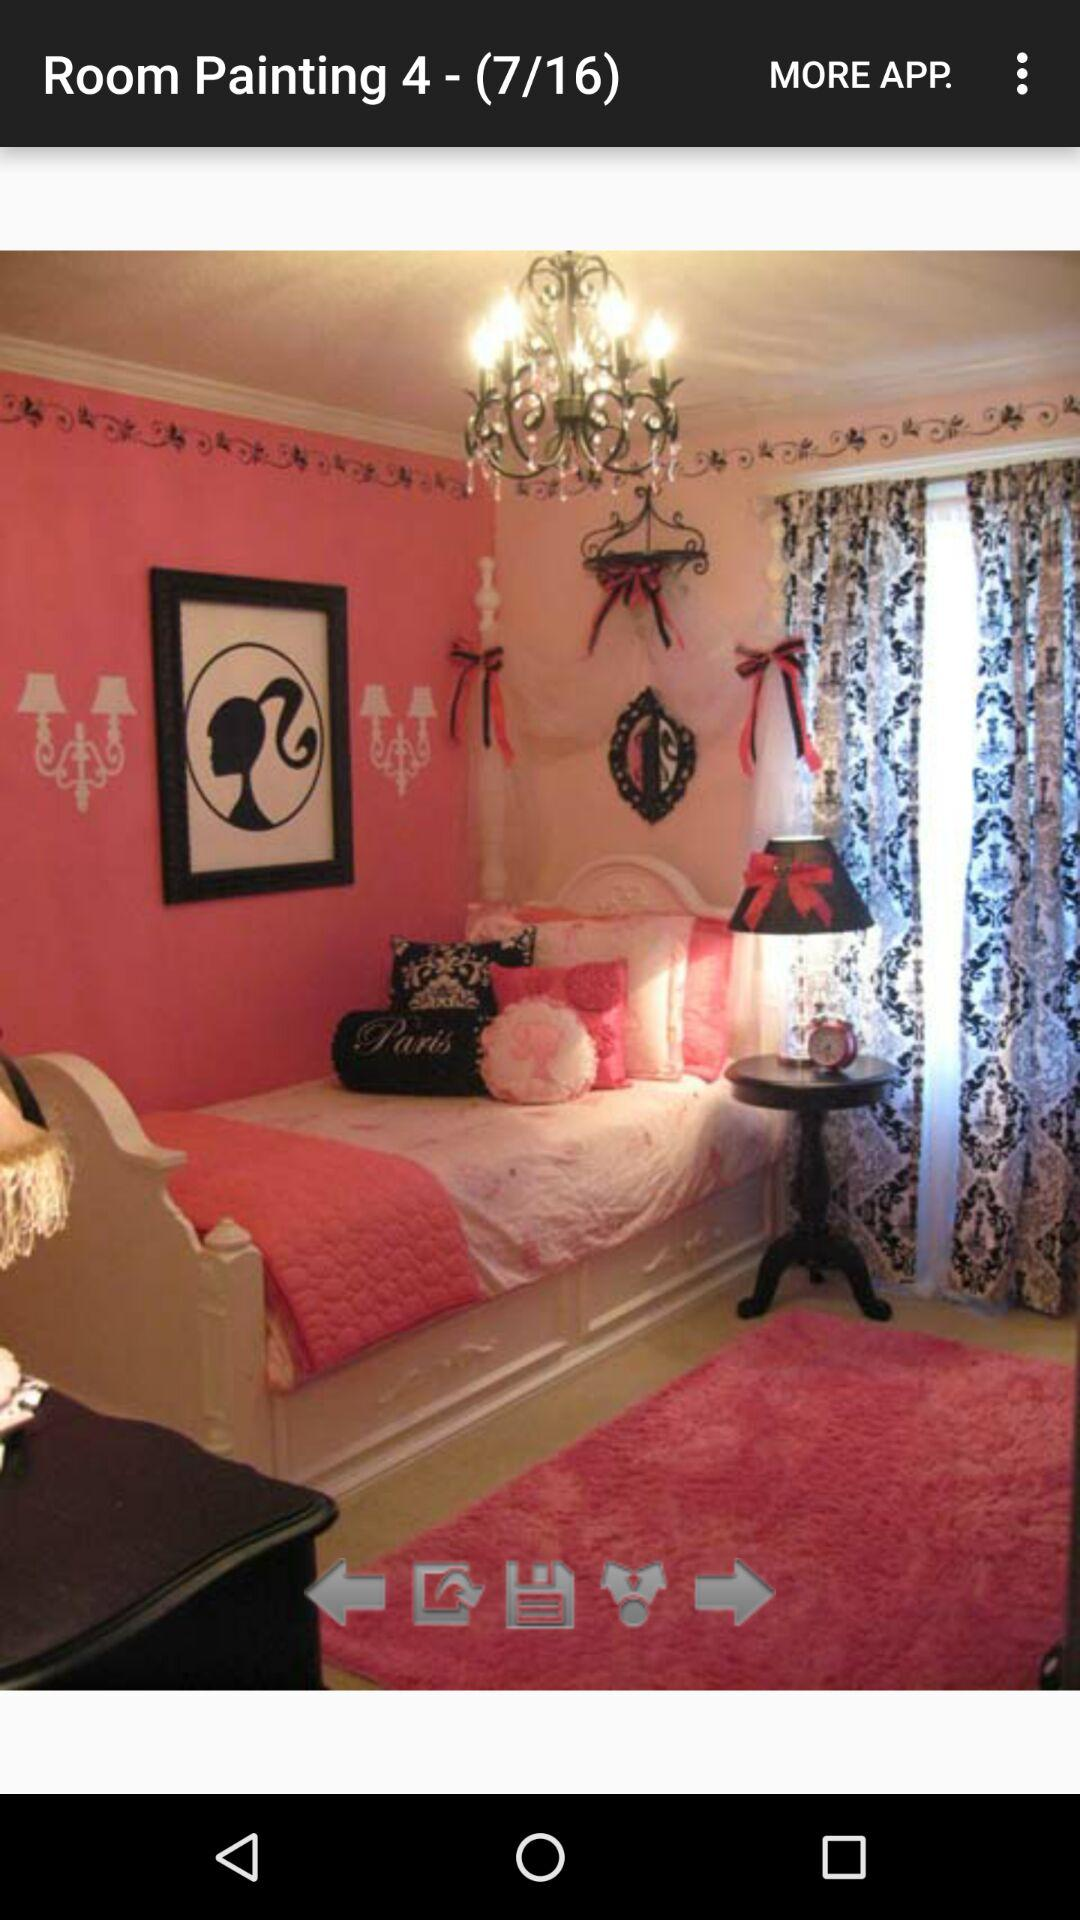What is the number of slides? The number of slides is 16. 